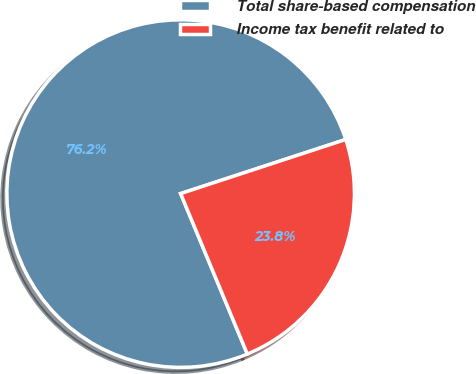Convert chart. <chart><loc_0><loc_0><loc_500><loc_500><pie_chart><fcel>Total share-based compensation<fcel>Income tax benefit related to<nl><fcel>76.23%<fcel>23.77%<nl></chart> 